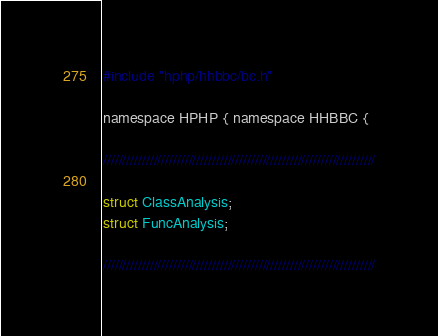<code> <loc_0><loc_0><loc_500><loc_500><_C_>#include "hphp/hhbbc/bc.h"

namespace HPHP { namespace HHBBC {

//////////////////////////////////////////////////////////////////////

struct ClassAnalysis;
struct FuncAnalysis;

//////////////////////////////////////////////////////////////////////
</code> 